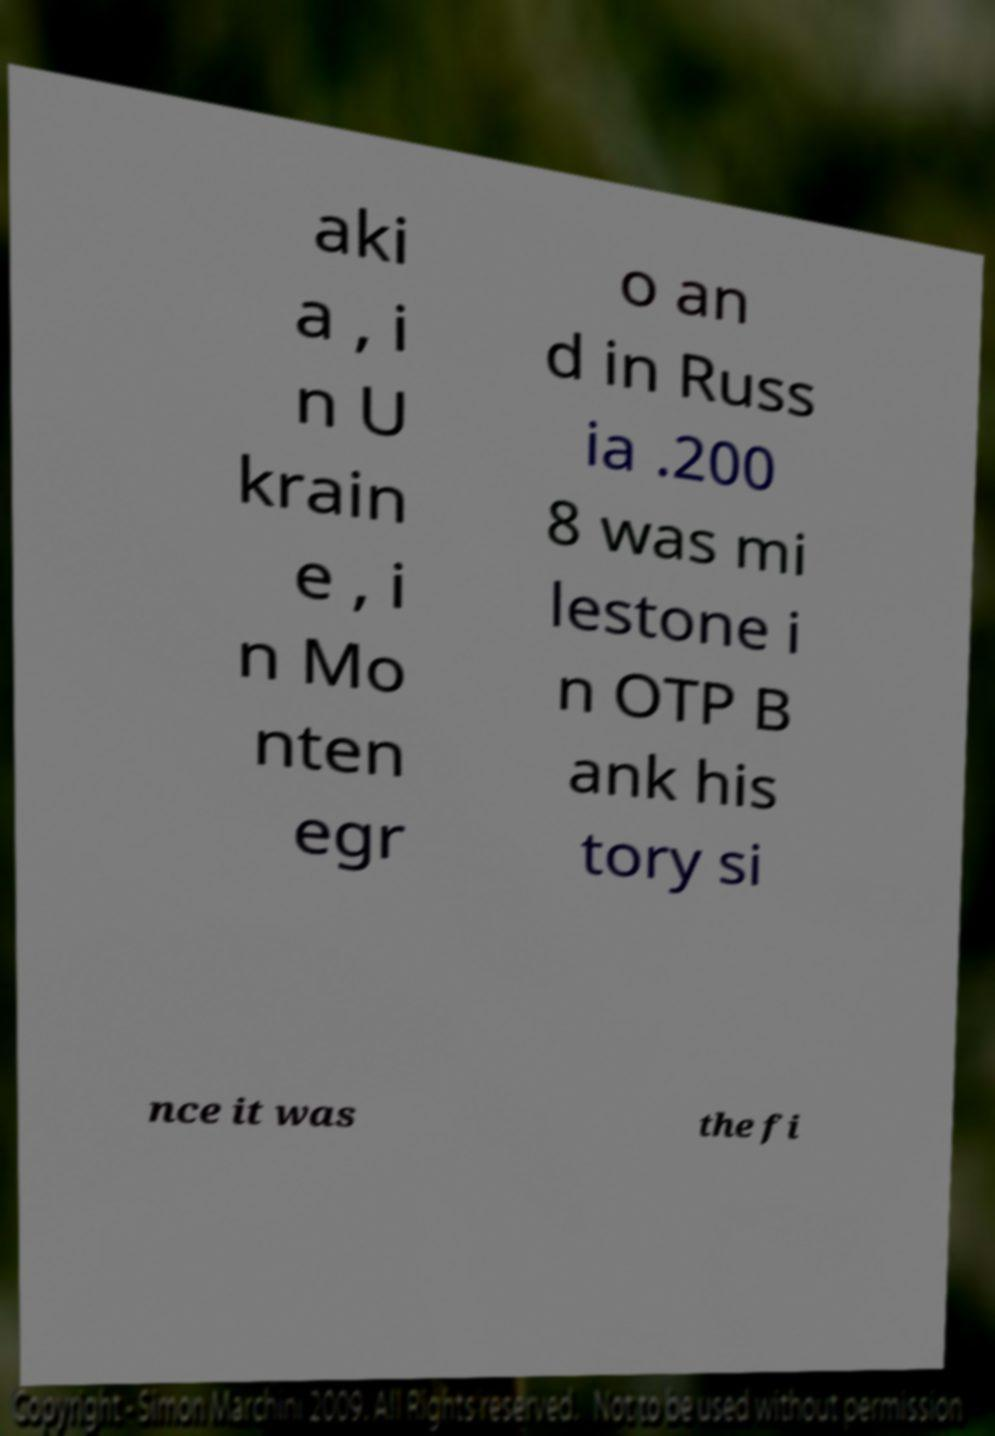Can you accurately transcribe the text from the provided image for me? aki a , i n U krain e , i n Mo nten egr o an d in Russ ia .200 8 was mi lestone i n OTP B ank his tory si nce it was the fi 